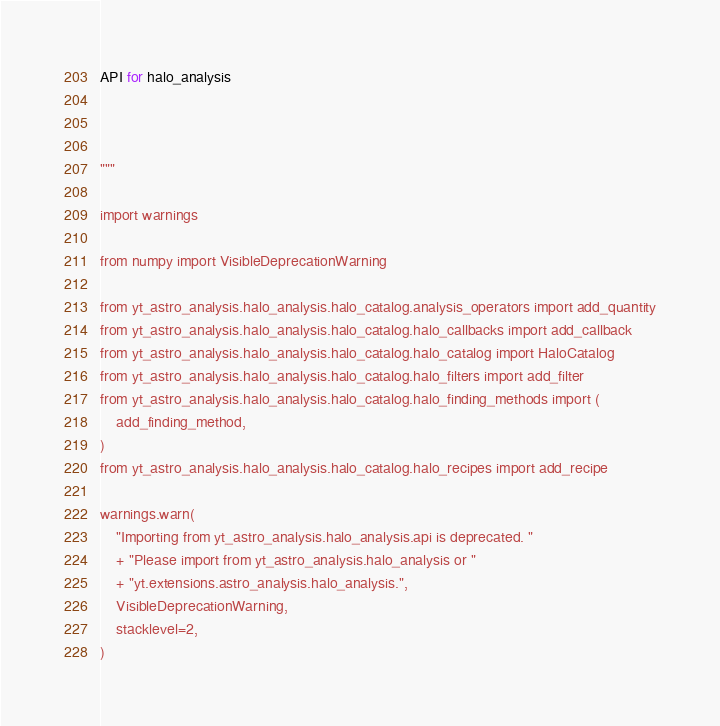<code> <loc_0><loc_0><loc_500><loc_500><_Python_>API for halo_analysis



"""

import warnings

from numpy import VisibleDeprecationWarning

from yt_astro_analysis.halo_analysis.halo_catalog.analysis_operators import add_quantity
from yt_astro_analysis.halo_analysis.halo_catalog.halo_callbacks import add_callback
from yt_astro_analysis.halo_analysis.halo_catalog.halo_catalog import HaloCatalog
from yt_astro_analysis.halo_analysis.halo_catalog.halo_filters import add_filter
from yt_astro_analysis.halo_analysis.halo_catalog.halo_finding_methods import (
    add_finding_method,
)
from yt_astro_analysis.halo_analysis.halo_catalog.halo_recipes import add_recipe

warnings.warn(
    "Importing from yt_astro_analysis.halo_analysis.api is deprecated. "
    + "Please import from yt_astro_analysis.halo_analysis or "
    + "yt.extensions.astro_analysis.halo_analysis.",
    VisibleDeprecationWarning,
    stacklevel=2,
)
</code> 